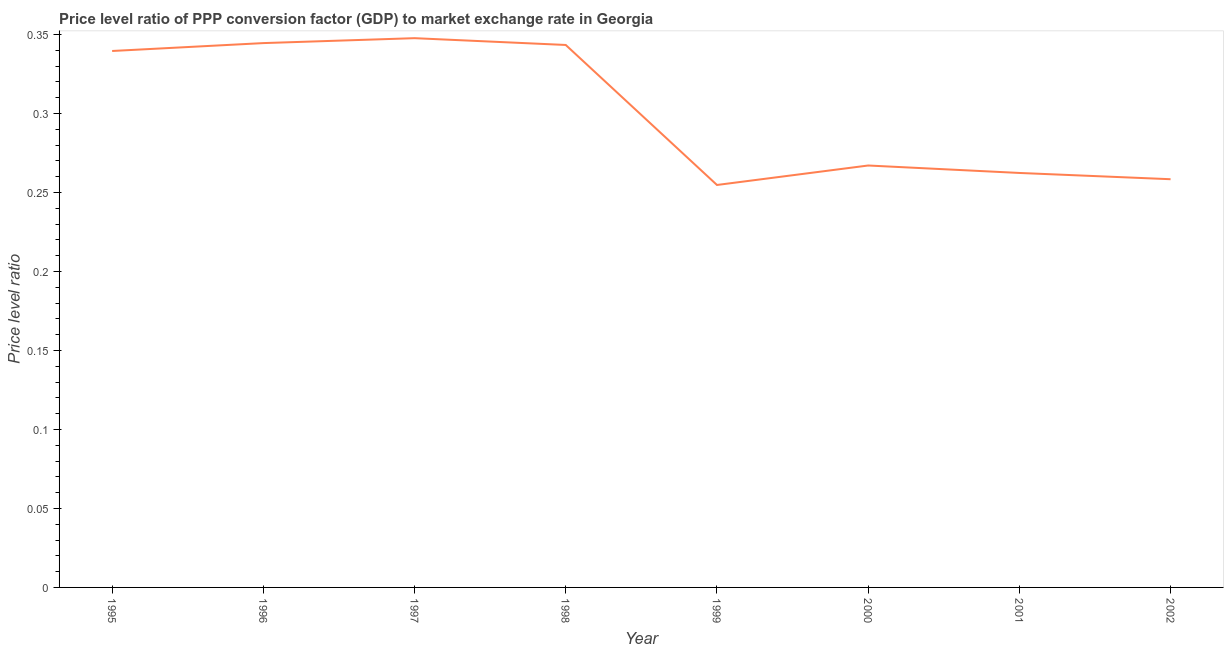What is the price level ratio in 1995?
Your answer should be compact. 0.34. Across all years, what is the maximum price level ratio?
Your answer should be compact. 0.35. Across all years, what is the minimum price level ratio?
Offer a very short reply. 0.25. In which year was the price level ratio maximum?
Provide a short and direct response. 1997. In which year was the price level ratio minimum?
Your response must be concise. 1999. What is the sum of the price level ratio?
Ensure brevity in your answer.  2.42. What is the difference between the price level ratio in 1996 and 2000?
Provide a short and direct response. 0.08. What is the average price level ratio per year?
Provide a succinct answer. 0.3. What is the median price level ratio?
Provide a succinct answer. 0.3. In how many years, is the price level ratio greater than 0.05 ?
Offer a very short reply. 8. Do a majority of the years between 1995 and 2001 (inclusive) have price level ratio greater than 0.12000000000000001 ?
Your answer should be compact. Yes. What is the ratio of the price level ratio in 1997 to that in 1998?
Keep it short and to the point. 1.01. Is the price level ratio in 1997 less than that in 2002?
Provide a short and direct response. No. What is the difference between the highest and the second highest price level ratio?
Your answer should be very brief. 0. What is the difference between the highest and the lowest price level ratio?
Your response must be concise. 0.09. Does the price level ratio monotonically increase over the years?
Offer a terse response. No. How many years are there in the graph?
Make the answer very short. 8. Are the values on the major ticks of Y-axis written in scientific E-notation?
Your answer should be compact. No. Does the graph contain grids?
Ensure brevity in your answer.  No. What is the title of the graph?
Your response must be concise. Price level ratio of PPP conversion factor (GDP) to market exchange rate in Georgia. What is the label or title of the Y-axis?
Keep it short and to the point. Price level ratio. What is the Price level ratio of 1995?
Offer a very short reply. 0.34. What is the Price level ratio of 1996?
Offer a terse response. 0.34. What is the Price level ratio of 1997?
Provide a succinct answer. 0.35. What is the Price level ratio of 1998?
Provide a short and direct response. 0.34. What is the Price level ratio of 1999?
Your answer should be very brief. 0.25. What is the Price level ratio of 2000?
Give a very brief answer. 0.27. What is the Price level ratio of 2001?
Offer a terse response. 0.26. What is the Price level ratio in 2002?
Your response must be concise. 0.26. What is the difference between the Price level ratio in 1995 and 1996?
Provide a short and direct response. -0. What is the difference between the Price level ratio in 1995 and 1997?
Provide a short and direct response. -0.01. What is the difference between the Price level ratio in 1995 and 1998?
Provide a short and direct response. -0. What is the difference between the Price level ratio in 1995 and 1999?
Ensure brevity in your answer.  0.08. What is the difference between the Price level ratio in 1995 and 2000?
Your answer should be compact. 0.07. What is the difference between the Price level ratio in 1995 and 2001?
Make the answer very short. 0.08. What is the difference between the Price level ratio in 1995 and 2002?
Provide a succinct answer. 0.08. What is the difference between the Price level ratio in 1996 and 1997?
Your response must be concise. -0. What is the difference between the Price level ratio in 1996 and 1998?
Provide a succinct answer. 0. What is the difference between the Price level ratio in 1996 and 1999?
Your answer should be compact. 0.09. What is the difference between the Price level ratio in 1996 and 2000?
Provide a succinct answer. 0.08. What is the difference between the Price level ratio in 1996 and 2001?
Your response must be concise. 0.08. What is the difference between the Price level ratio in 1996 and 2002?
Your answer should be compact. 0.09. What is the difference between the Price level ratio in 1997 and 1998?
Make the answer very short. 0. What is the difference between the Price level ratio in 1997 and 1999?
Ensure brevity in your answer.  0.09. What is the difference between the Price level ratio in 1997 and 2000?
Provide a short and direct response. 0.08. What is the difference between the Price level ratio in 1997 and 2001?
Give a very brief answer. 0.09. What is the difference between the Price level ratio in 1997 and 2002?
Your answer should be very brief. 0.09. What is the difference between the Price level ratio in 1998 and 1999?
Your answer should be very brief. 0.09. What is the difference between the Price level ratio in 1998 and 2000?
Provide a succinct answer. 0.08. What is the difference between the Price level ratio in 1998 and 2001?
Keep it short and to the point. 0.08. What is the difference between the Price level ratio in 1998 and 2002?
Offer a terse response. 0.08. What is the difference between the Price level ratio in 1999 and 2000?
Keep it short and to the point. -0.01. What is the difference between the Price level ratio in 1999 and 2001?
Offer a terse response. -0.01. What is the difference between the Price level ratio in 1999 and 2002?
Give a very brief answer. -0. What is the difference between the Price level ratio in 2000 and 2001?
Ensure brevity in your answer.  0. What is the difference between the Price level ratio in 2000 and 2002?
Give a very brief answer. 0.01. What is the difference between the Price level ratio in 2001 and 2002?
Offer a very short reply. 0. What is the ratio of the Price level ratio in 1995 to that in 1999?
Your answer should be very brief. 1.33. What is the ratio of the Price level ratio in 1995 to that in 2000?
Provide a succinct answer. 1.27. What is the ratio of the Price level ratio in 1995 to that in 2001?
Your response must be concise. 1.29. What is the ratio of the Price level ratio in 1995 to that in 2002?
Your answer should be very brief. 1.31. What is the ratio of the Price level ratio in 1996 to that in 1997?
Provide a short and direct response. 0.99. What is the ratio of the Price level ratio in 1996 to that in 1999?
Provide a succinct answer. 1.35. What is the ratio of the Price level ratio in 1996 to that in 2000?
Provide a short and direct response. 1.29. What is the ratio of the Price level ratio in 1996 to that in 2001?
Offer a very short reply. 1.31. What is the ratio of the Price level ratio in 1996 to that in 2002?
Your answer should be very brief. 1.33. What is the ratio of the Price level ratio in 1997 to that in 1999?
Your answer should be compact. 1.36. What is the ratio of the Price level ratio in 1997 to that in 2000?
Offer a terse response. 1.3. What is the ratio of the Price level ratio in 1997 to that in 2001?
Keep it short and to the point. 1.32. What is the ratio of the Price level ratio in 1997 to that in 2002?
Your response must be concise. 1.35. What is the ratio of the Price level ratio in 1998 to that in 1999?
Your answer should be compact. 1.35. What is the ratio of the Price level ratio in 1998 to that in 2000?
Your answer should be very brief. 1.29. What is the ratio of the Price level ratio in 1998 to that in 2001?
Your answer should be very brief. 1.31. What is the ratio of the Price level ratio in 1998 to that in 2002?
Ensure brevity in your answer.  1.33. What is the ratio of the Price level ratio in 1999 to that in 2000?
Provide a succinct answer. 0.95. What is the ratio of the Price level ratio in 1999 to that in 2001?
Your response must be concise. 0.97. What is the ratio of the Price level ratio in 2000 to that in 2002?
Provide a succinct answer. 1.03. What is the ratio of the Price level ratio in 2001 to that in 2002?
Your answer should be compact. 1.01. 